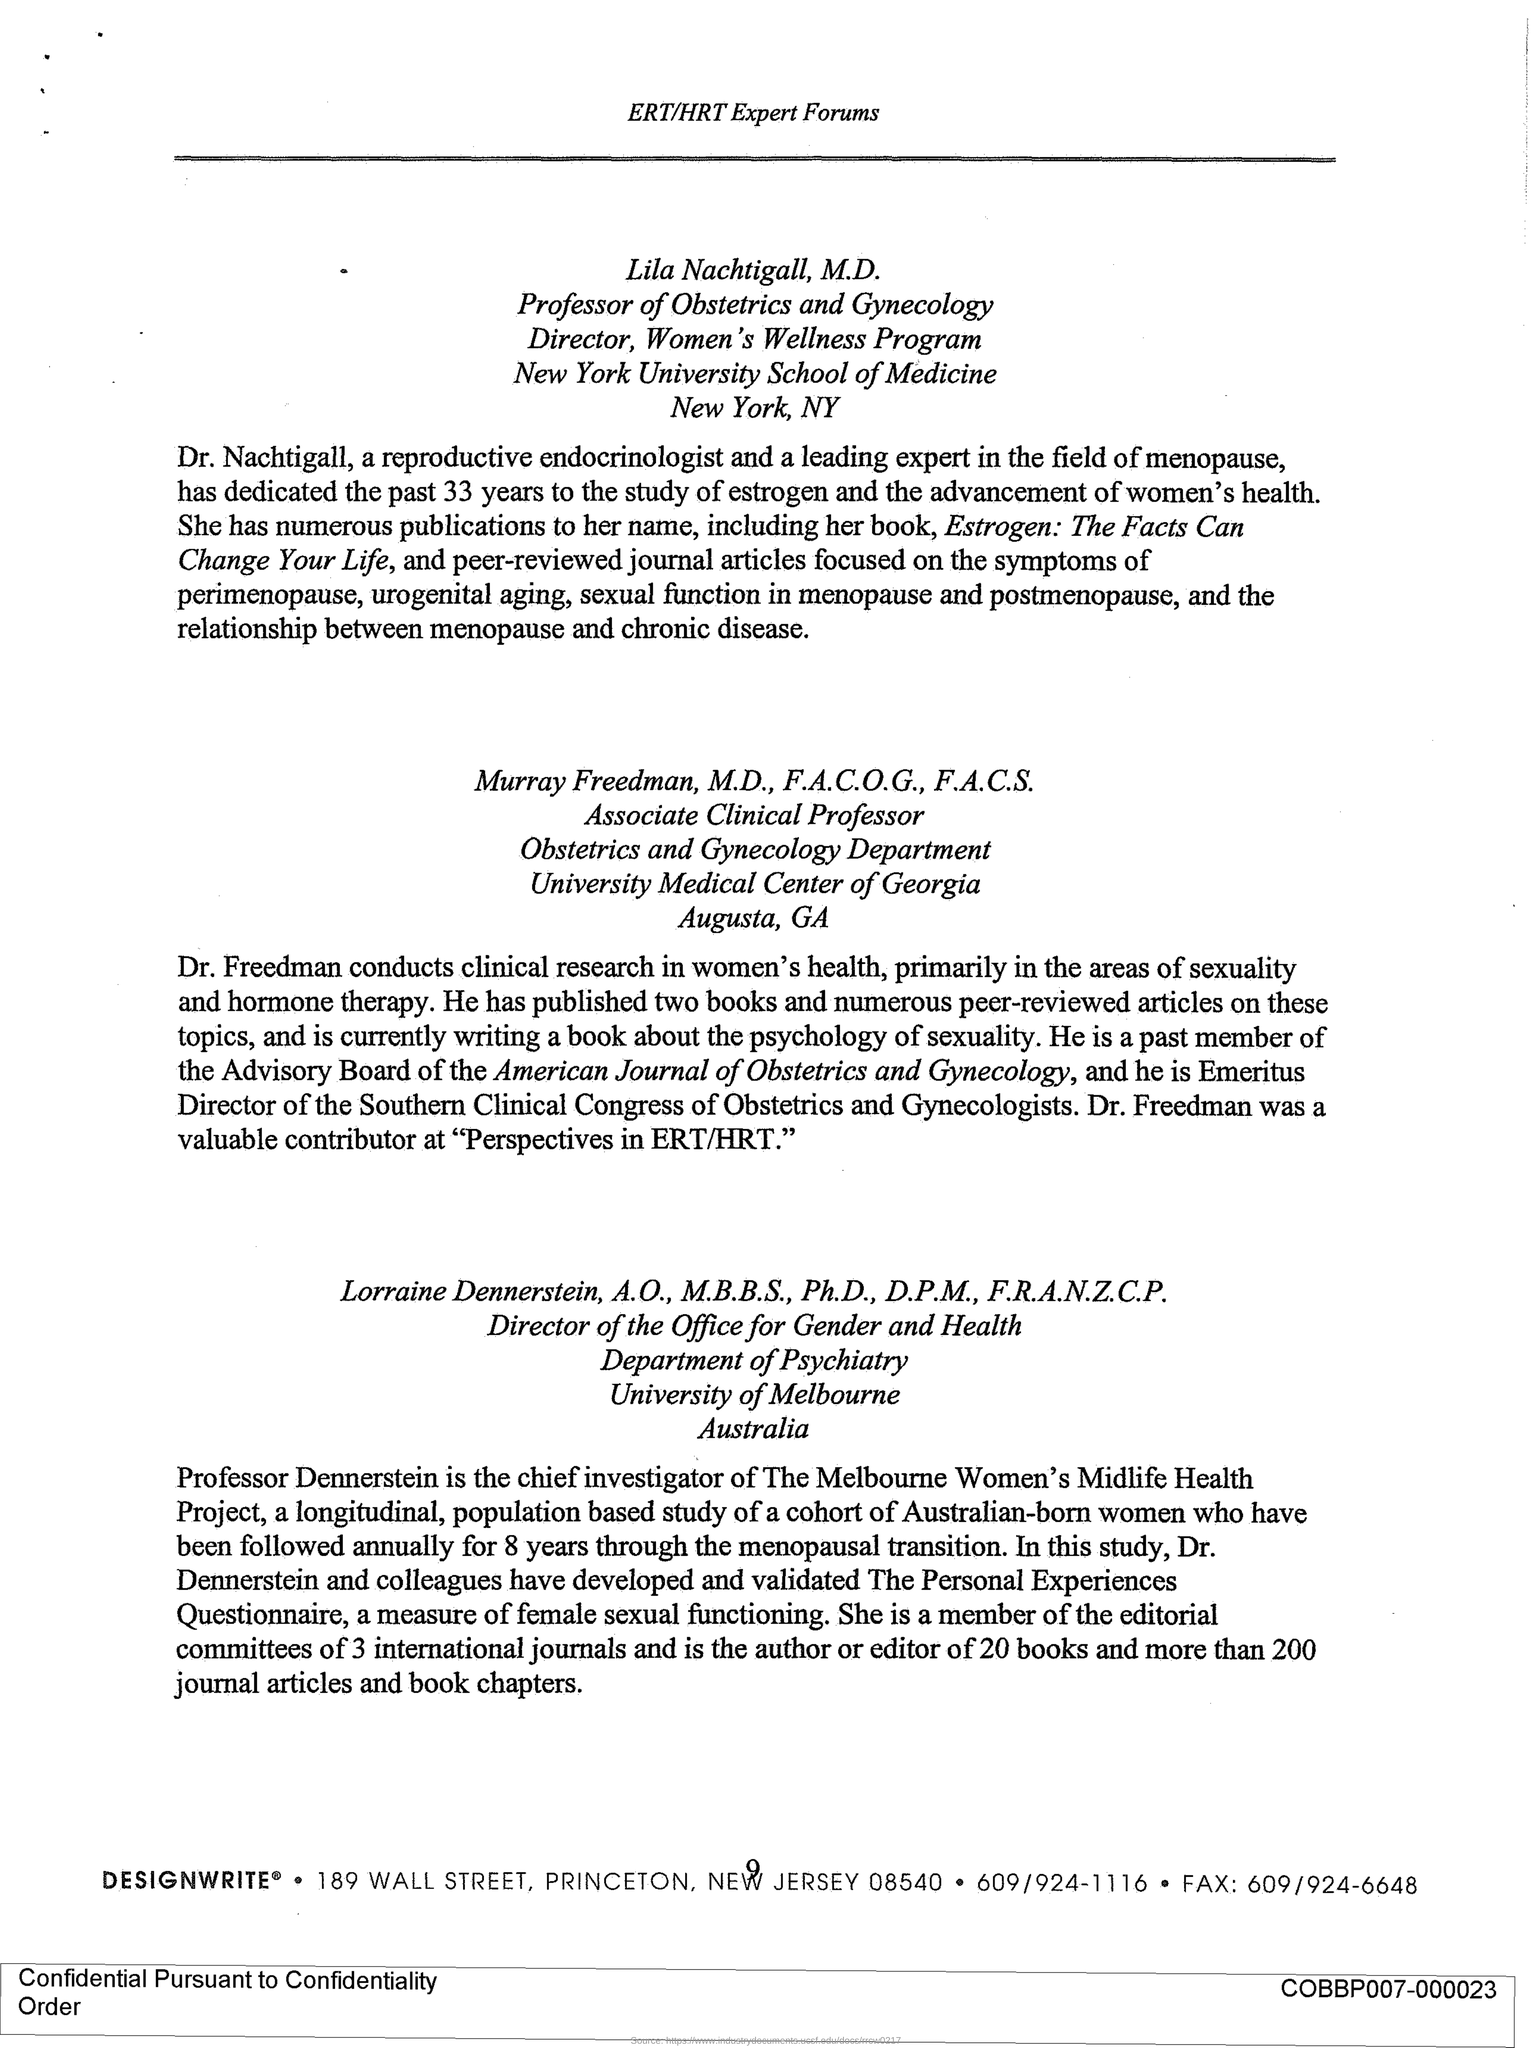What is the Page Number?
Provide a short and direct response. 9. What is the designation of Lila Nachtigall?
Provide a succinct answer. Professor of Obstetrics and Gynecology. What is the designation of Murray Freedman?
Offer a very short reply. Associate Clinical Professor. What is the designation of Lorraine Dennerstein?
Offer a terse response. Director of the Office for Gender and Health. 